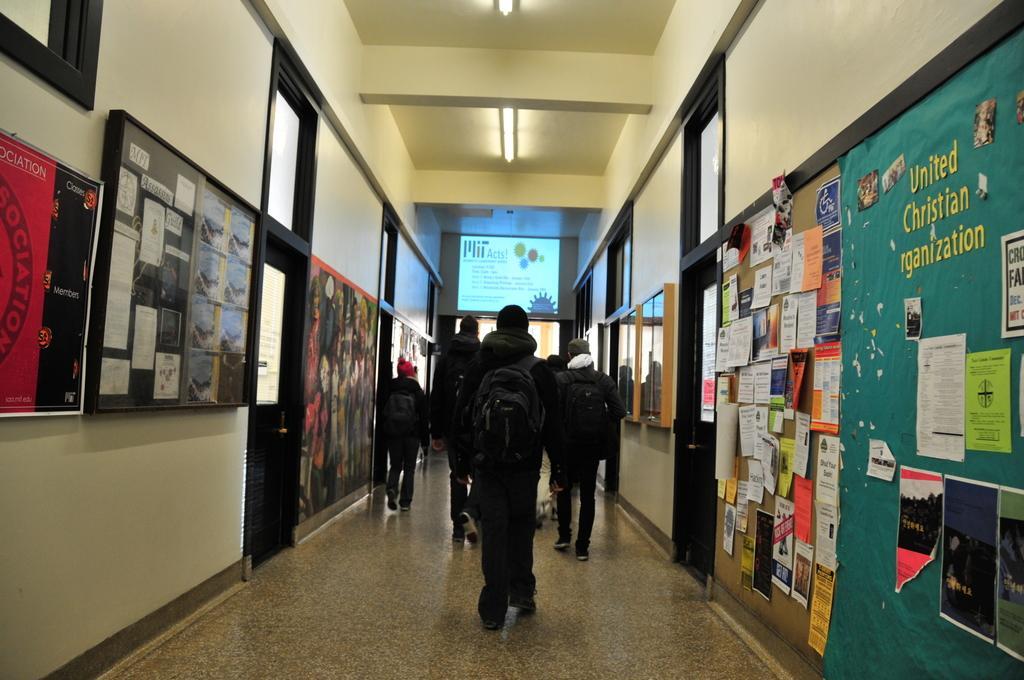Could you give a brief overview of what you see in this image? In this image I can see the group of people with black color dresses and the bags. On both sides of these people I can see the boards and the papers attached to the wall. In the background I can see the screen and the lights at the top. 